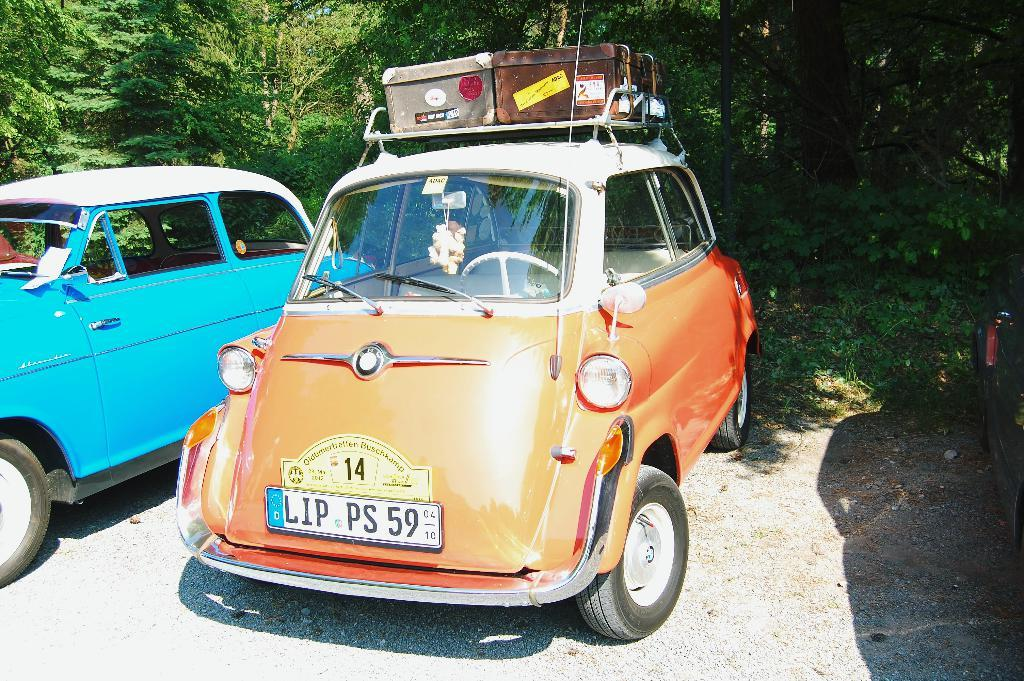What type of vehicles are on the ground in the image? There are cars on the ground in the image. What additional feature can be seen on one of the cars? Trunk boxes are present on top of a car in the image. What can be seen in the distance in the image? There are trees visible in the background of the image. How many cattle can be seen grazing in the image? There are no cattle present in the image. What type of skin condition is visible on the car in the image? There is no skin condition visible on the car in the image; it is a vehicle, not a living organism. 